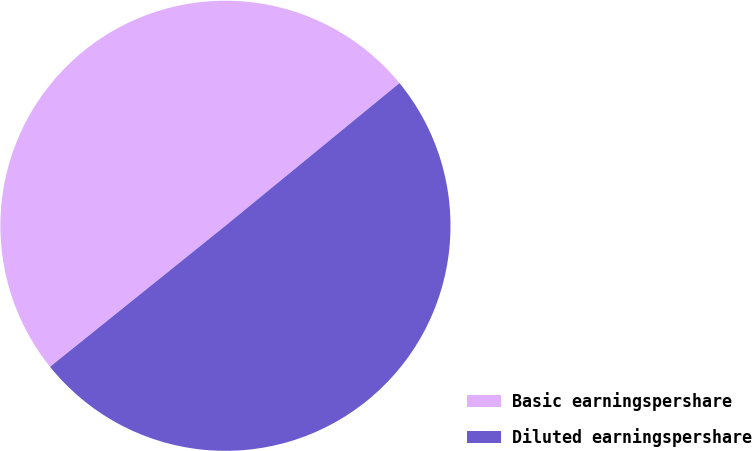Convert chart. <chart><loc_0><loc_0><loc_500><loc_500><pie_chart><fcel>Basic earningspershare<fcel>Diluted earningspershare<nl><fcel>49.85%<fcel>50.15%<nl></chart> 